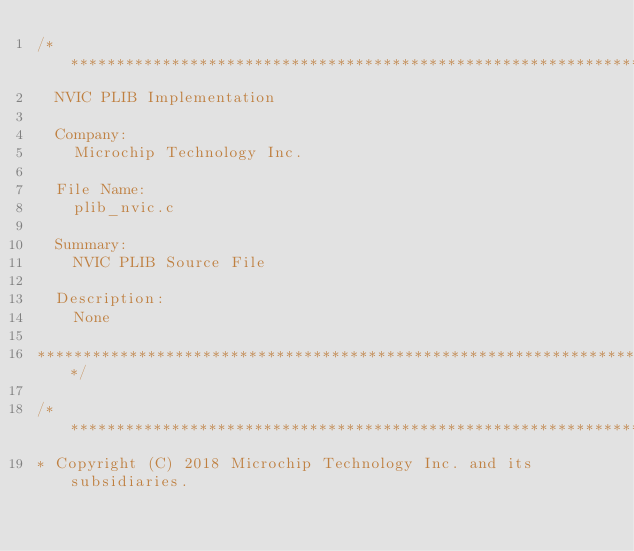<code> <loc_0><loc_0><loc_500><loc_500><_C_>/*******************************************************************************
  NVIC PLIB Implementation

  Company:
    Microchip Technology Inc.

  File Name:
    plib_nvic.c

  Summary:
    NVIC PLIB Source File

  Description:
    None

*******************************************************************************/

/*******************************************************************************
* Copyright (C) 2018 Microchip Technology Inc. and its subsidiaries.</code> 